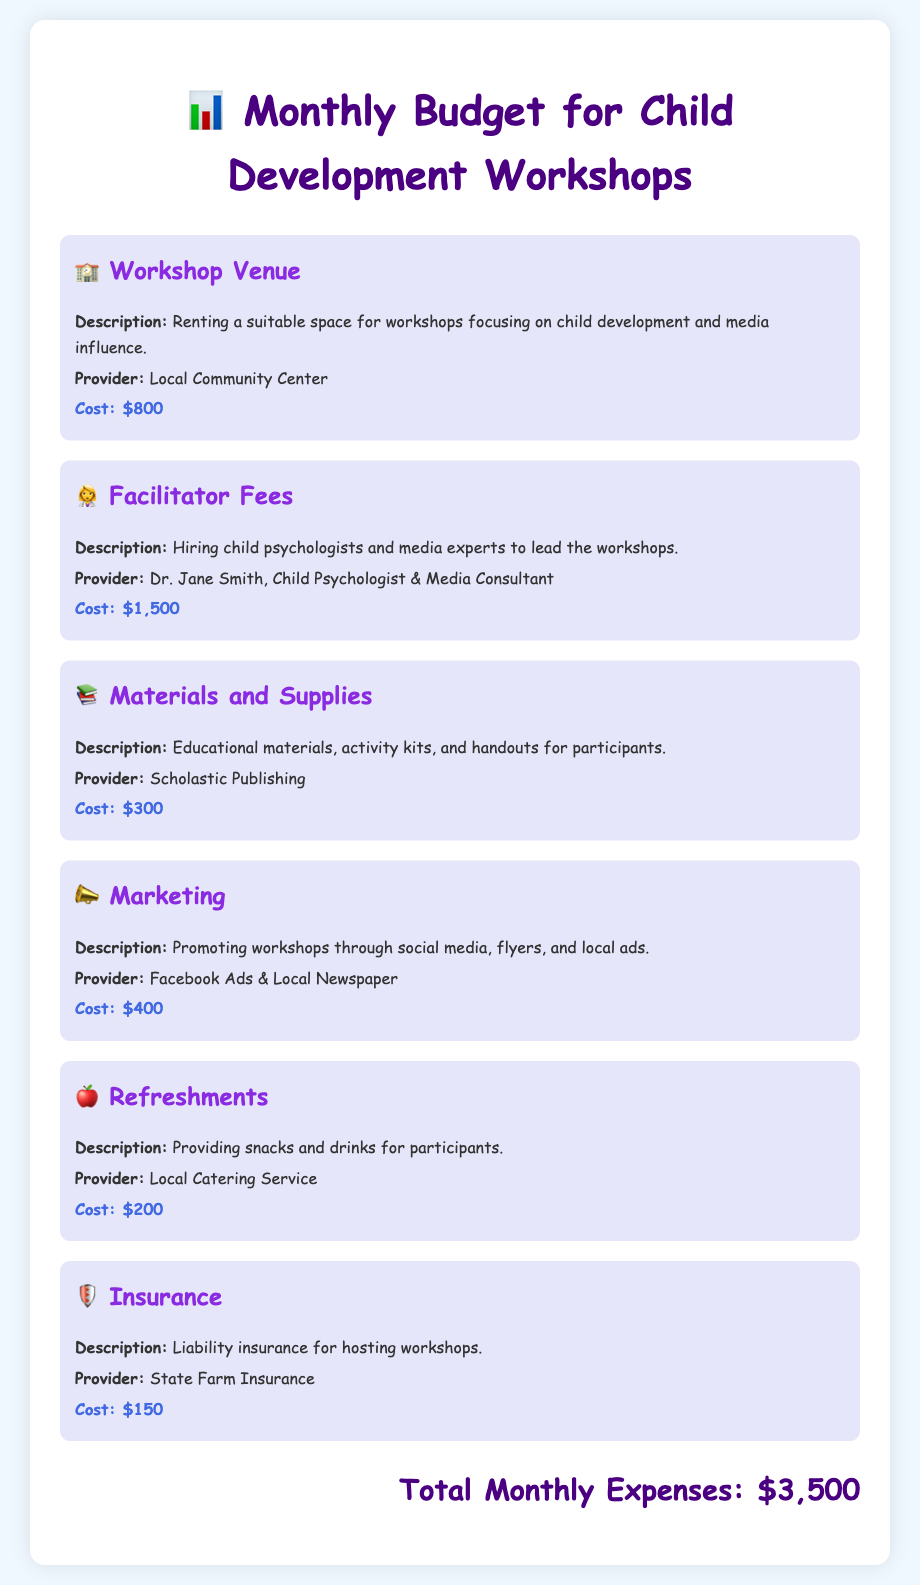What is the total monthly expenses? The total monthly expenses are listed at the bottom of the document, which shows the amount of $3,500.
Answer: $3,500 Who is the provider for the facilitator fees? The provider for the facilitator fees is mentioned in the document as Dr. Jane Smith, Child Psychologist & Media Consultant.
Answer: Dr. Jane Smith How much is allocated for materials and supplies? The document specifies the cost for materials and supplies as $300.
Answer: $300 What type of insurance is included in the budget? The document states that the insurance included is liability insurance for hosting workshops.
Answer: Liability insurance Which service provides refreshments? The document notes that a Local Catering Service is responsible for providing refreshments.
Answer: Local Catering Service How many budget items are listed? There are six budget items detailed in the document for the workshops.
Answer: Six What is the cost for marketing? The document lists the cost for marketing as $400.
Answer: $400 What are the workshops focusing on? The document indicates that the workshops focus on child development and media influence.
Answer: Child development and media influence Who provides the workshop venue? The provider for the workshop venue is the Local Community Center as stated in the document.
Answer: Local Community Center 